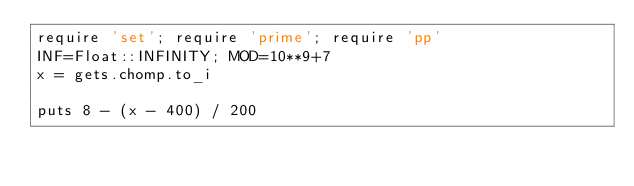<code> <loc_0><loc_0><loc_500><loc_500><_Ruby_>require 'set'; require 'prime'; require 'pp'
INF=Float::INFINITY; MOD=10**9+7
x = gets.chomp.to_i

puts 8 - (x - 400) / 200

</code> 